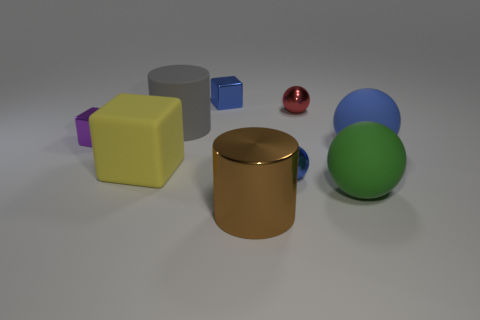What size is the matte ball behind the blue metallic thing to the right of the large metal object?
Offer a very short reply. Large. Are there more tiny things than cylinders?
Your response must be concise. Yes. There is a rubber thing that is behind the blue matte sphere; is its size the same as the big brown metal object?
Offer a very short reply. Yes. Is the large blue object the same shape as the big yellow matte thing?
Keep it short and to the point. No. There is a rubber thing that is the same shape as the brown metal object; what size is it?
Your response must be concise. Large. Is the number of small spheres in front of the yellow thing greater than the number of large brown metallic objects that are right of the large brown metal object?
Make the answer very short. Yes. Do the red sphere and the tiny blue thing in front of the rubber cylinder have the same material?
Offer a very short reply. Yes. What color is the thing that is both in front of the small purple metal cube and left of the large gray thing?
Offer a terse response. Yellow. What shape is the blue metal thing that is in front of the large gray thing?
Ensure brevity in your answer.  Sphere. There is a cylinder to the left of the cylinder right of the tiny blue thing behind the rubber cube; how big is it?
Offer a very short reply. Large. 